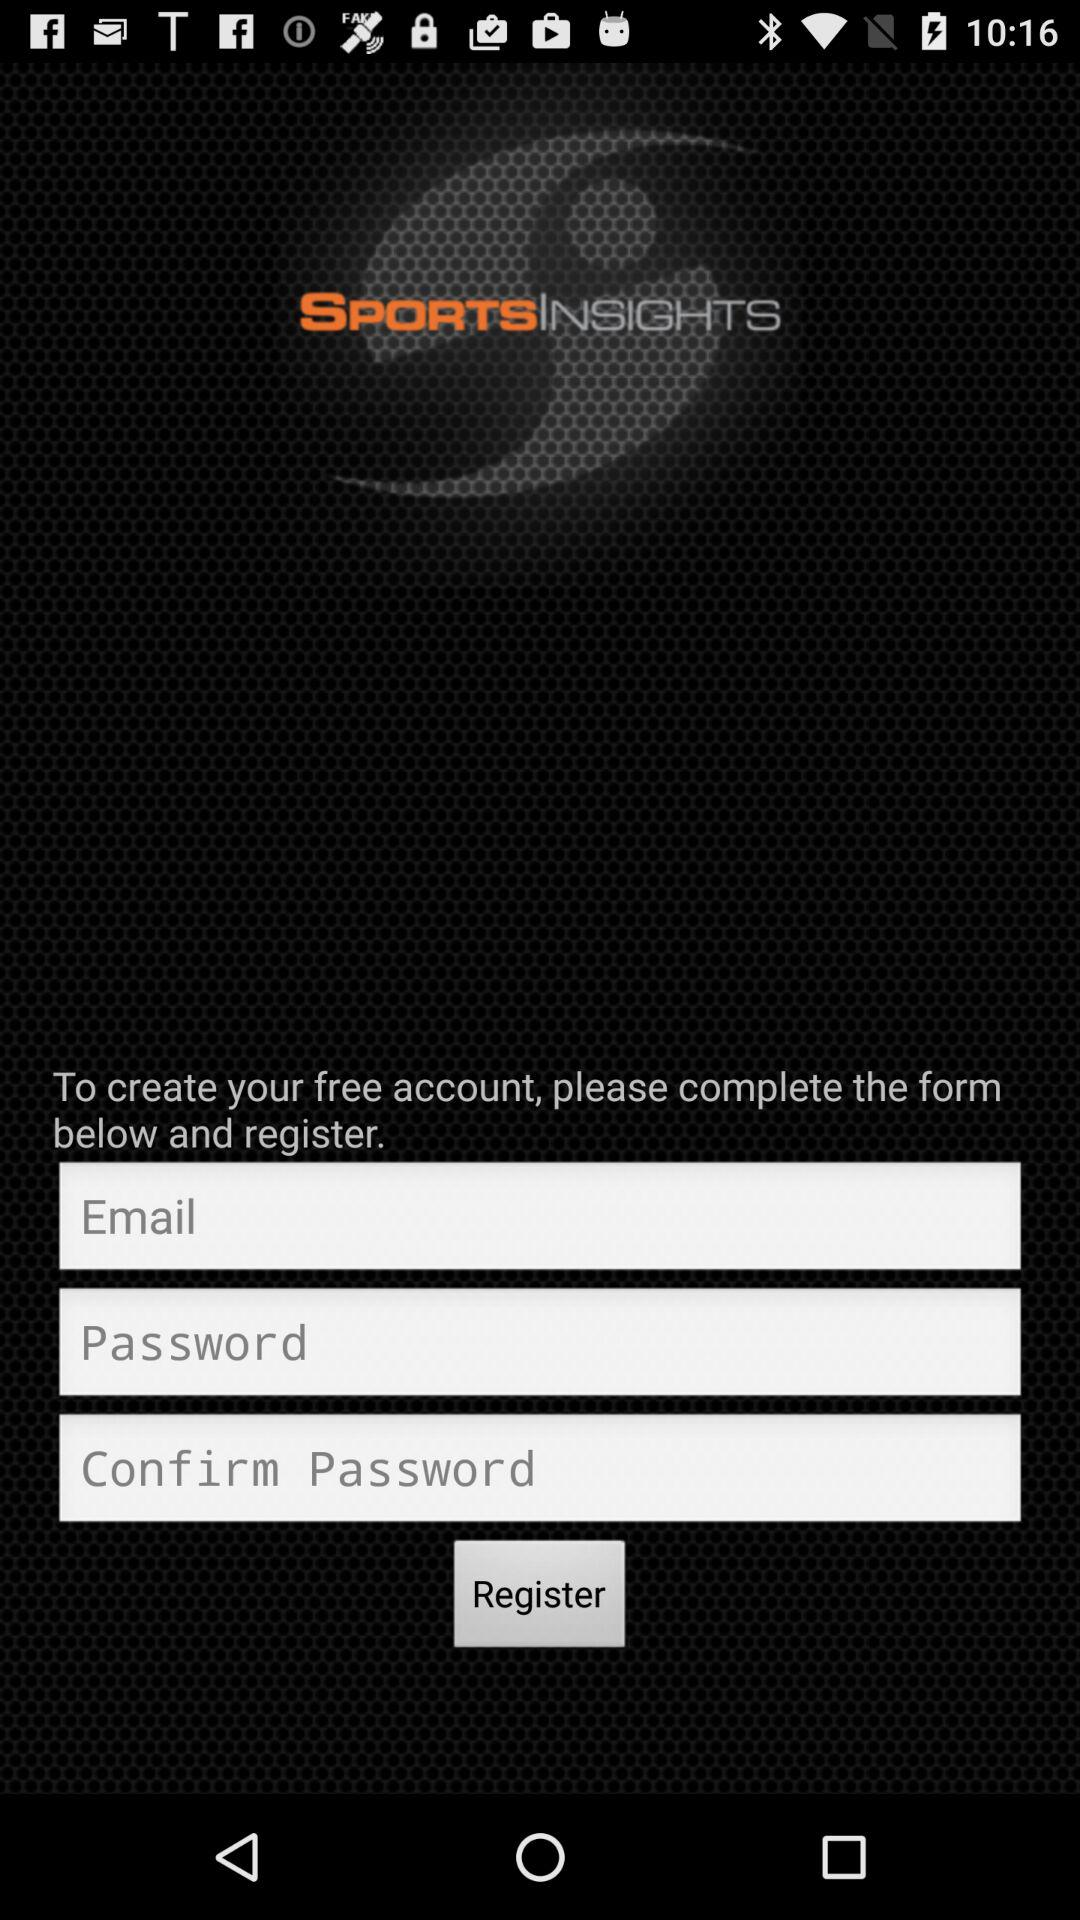What is the name of the application? The name of the application is "SPORTSINSIGHTS". 